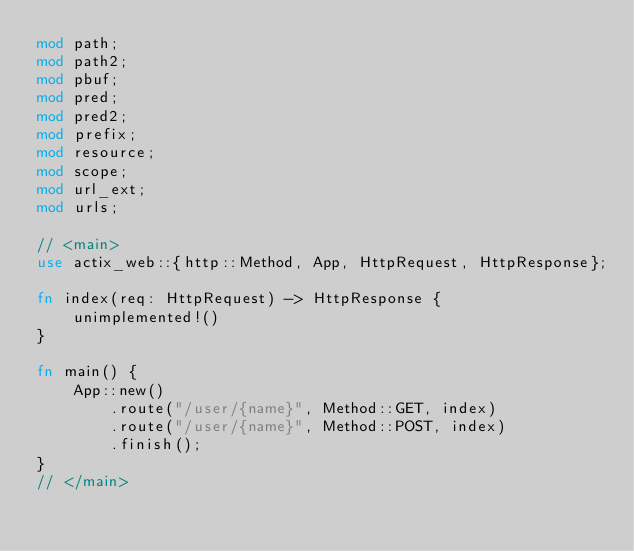Convert code to text. <code><loc_0><loc_0><loc_500><loc_500><_Rust_>mod path;
mod path2;
mod pbuf;
mod pred;
mod pred2;
mod prefix;
mod resource;
mod scope;
mod url_ext;
mod urls;

// <main>
use actix_web::{http::Method, App, HttpRequest, HttpResponse};

fn index(req: HttpRequest) -> HttpResponse {
    unimplemented!()
}

fn main() {
    App::new()
        .route("/user/{name}", Method::GET, index)
        .route("/user/{name}", Method::POST, index)
        .finish();
}
// </main>
</code> 